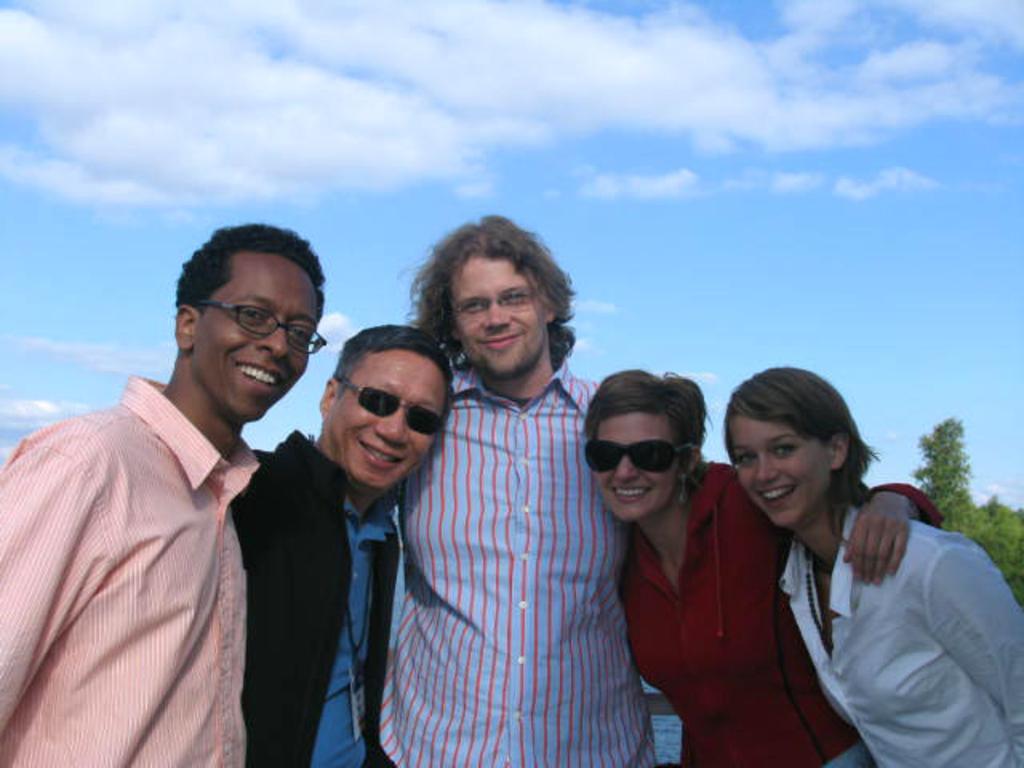In one or two sentences, can you explain what this image depicts? In this image I can see few persons are standing and smiling. I can see few of them are wearing spectacles. In the background I can see few trees which are green in color and the sky. 